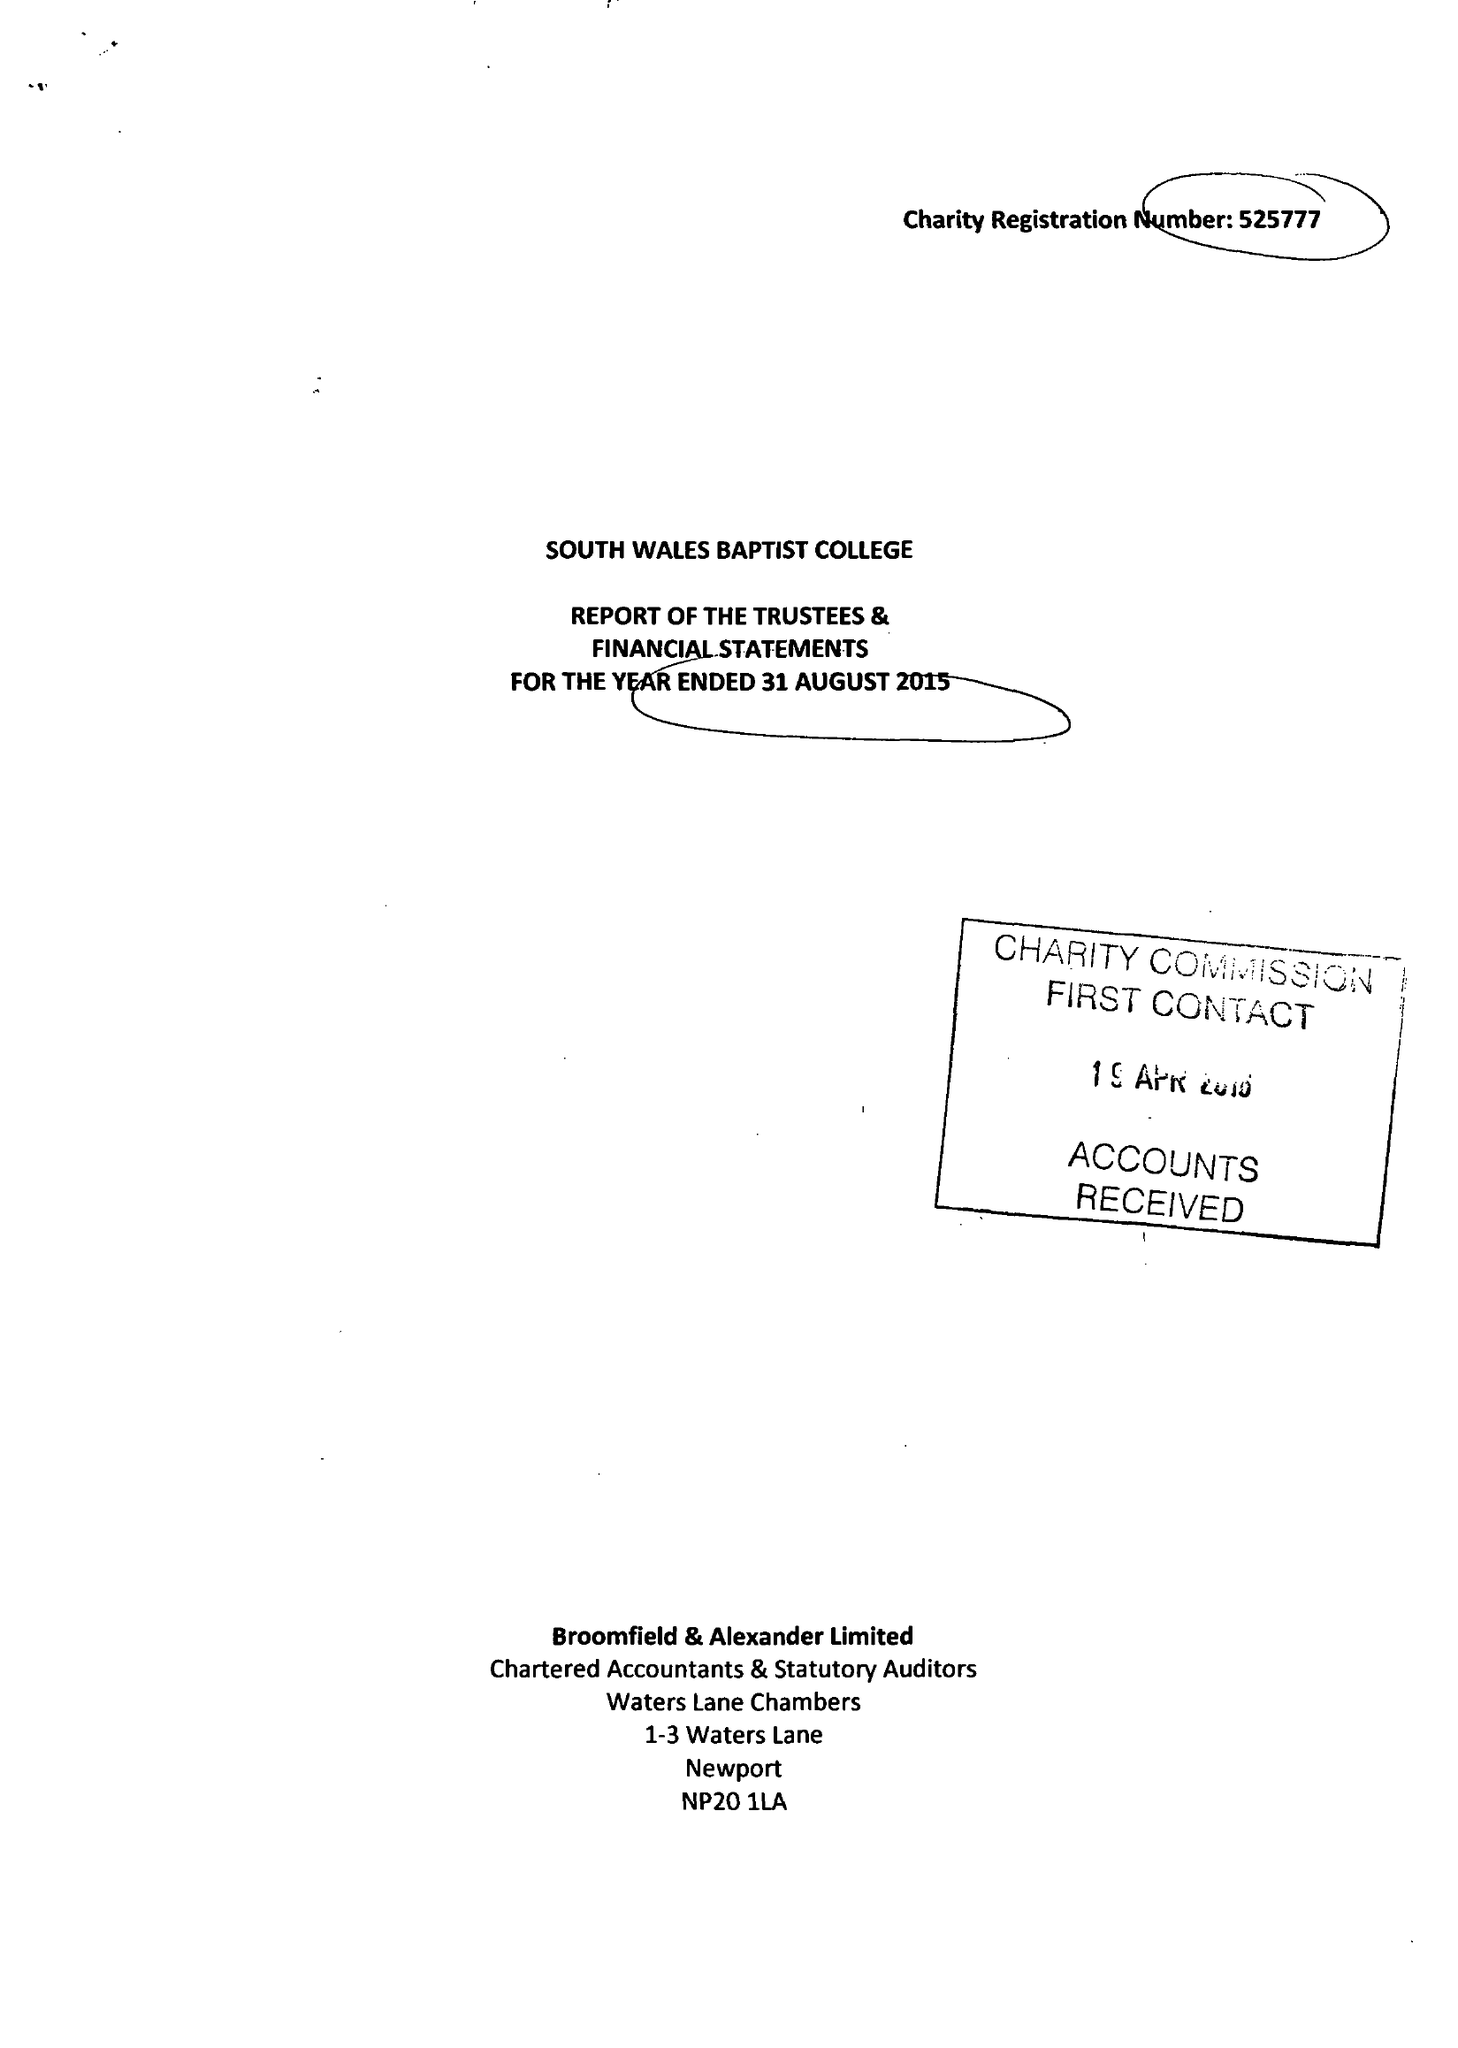What is the value for the charity_number?
Answer the question using a single word or phrase. 525777 